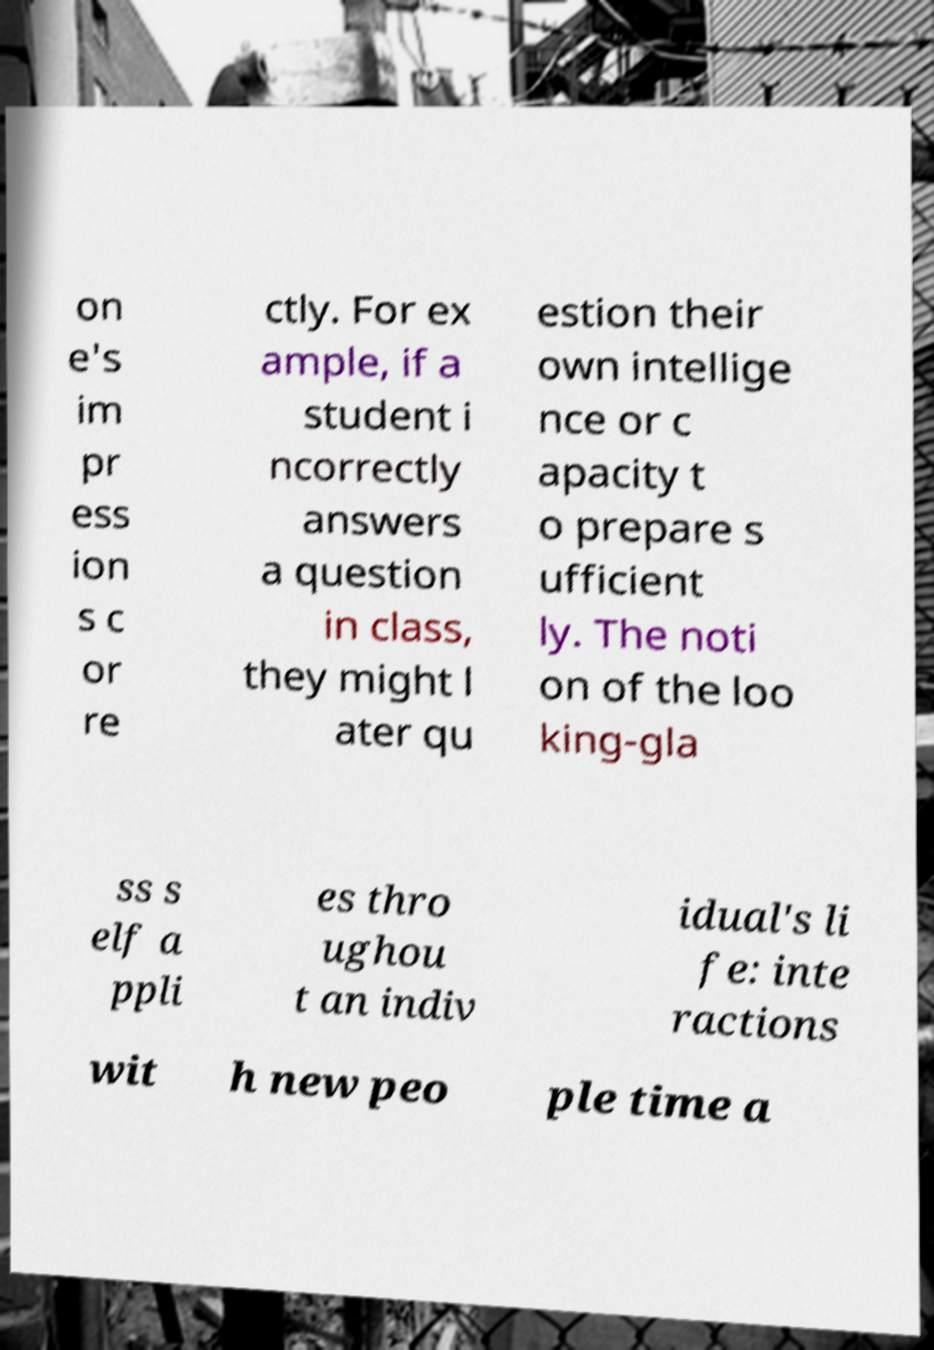Can you accurately transcribe the text from the provided image for me? on e's im pr ess ion s c or re ctly. For ex ample, if a student i ncorrectly answers a question in class, they might l ater qu estion their own intellige nce or c apacity t o prepare s ufficient ly. The noti on of the loo king-gla ss s elf a ppli es thro ughou t an indiv idual's li fe: inte ractions wit h new peo ple time a 